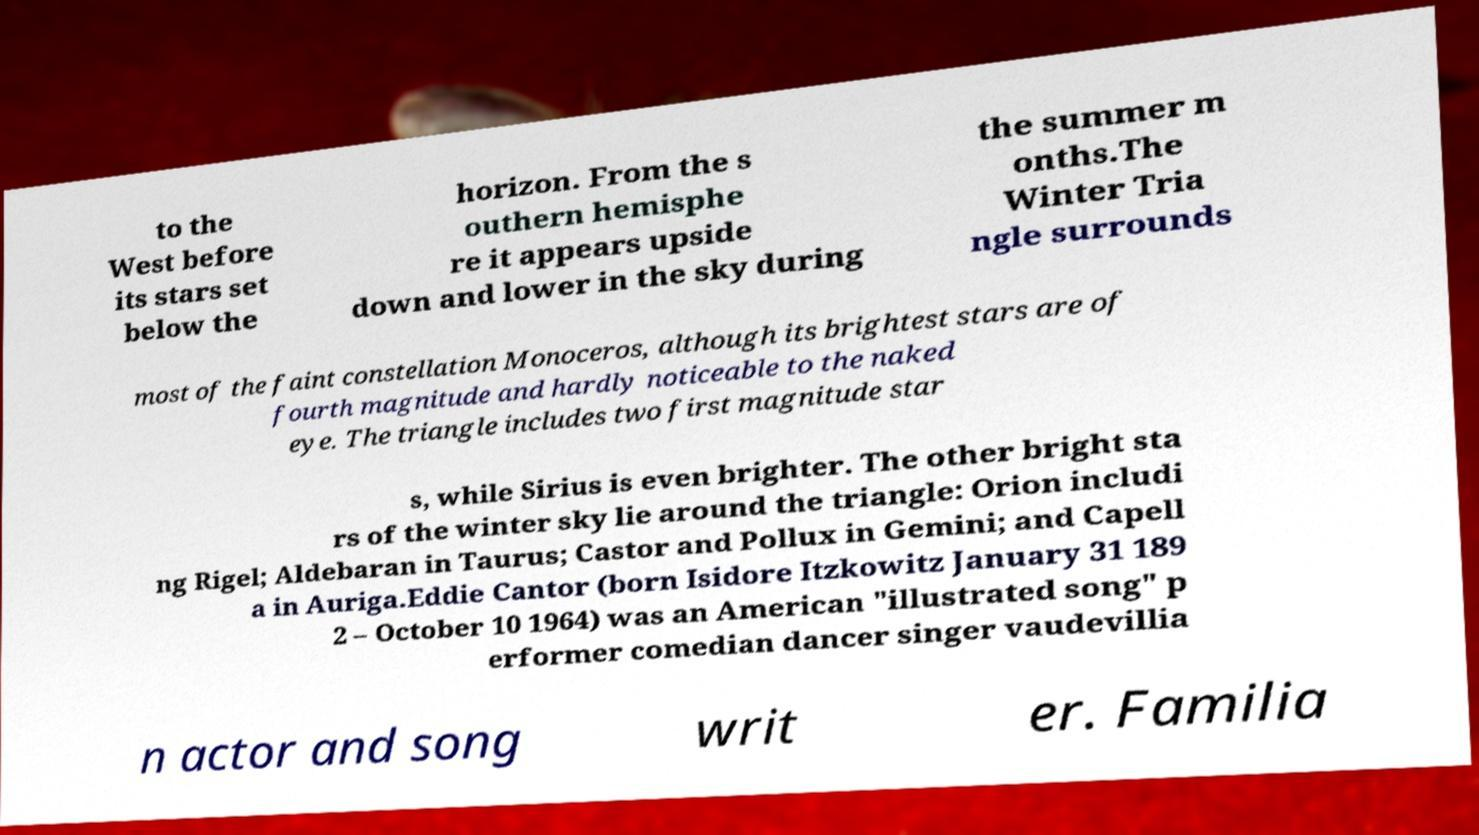Could you assist in decoding the text presented in this image and type it out clearly? to the West before its stars set below the horizon. From the s outhern hemisphe re it appears upside down and lower in the sky during the summer m onths.The Winter Tria ngle surrounds most of the faint constellation Monoceros, although its brightest stars are of fourth magnitude and hardly noticeable to the naked eye. The triangle includes two first magnitude star s, while Sirius is even brighter. The other bright sta rs of the winter sky lie around the triangle: Orion includi ng Rigel; Aldebaran in Taurus; Castor and Pollux in Gemini; and Capell a in Auriga.Eddie Cantor (born Isidore Itzkowitz January 31 189 2 – October 10 1964) was an American "illustrated song" p erformer comedian dancer singer vaudevillia n actor and song writ er. Familia 